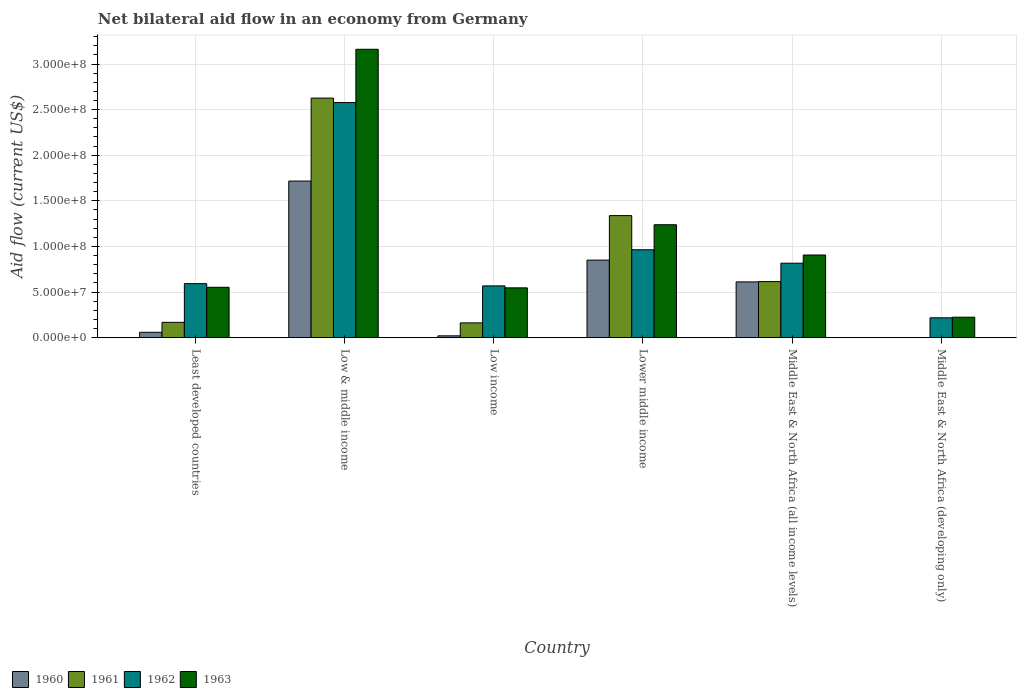How many groups of bars are there?
Offer a very short reply. 6. Are the number of bars on each tick of the X-axis equal?
Provide a succinct answer. No. What is the label of the 5th group of bars from the left?
Your answer should be very brief. Middle East & North Africa (all income levels). What is the net bilateral aid flow in 1960 in Low income?
Your response must be concise. 2.02e+06. Across all countries, what is the maximum net bilateral aid flow in 1962?
Ensure brevity in your answer.  2.58e+08. Across all countries, what is the minimum net bilateral aid flow in 1960?
Offer a terse response. 0. In which country was the net bilateral aid flow in 1961 maximum?
Provide a succinct answer. Low & middle income. What is the total net bilateral aid flow in 1963 in the graph?
Your answer should be very brief. 6.63e+08. What is the difference between the net bilateral aid flow in 1962 in Lower middle income and that in Middle East & North Africa (all income levels)?
Keep it short and to the point. 1.47e+07. What is the difference between the net bilateral aid flow in 1960 in Low income and the net bilateral aid flow in 1962 in Middle East & North Africa (all income levels)?
Your answer should be compact. -7.96e+07. What is the average net bilateral aid flow in 1962 per country?
Make the answer very short. 9.56e+07. What is the difference between the net bilateral aid flow of/in 1963 and net bilateral aid flow of/in 1962 in Low & middle income?
Offer a very short reply. 5.84e+07. What is the ratio of the net bilateral aid flow in 1960 in Lower middle income to that in Middle East & North Africa (all income levels)?
Offer a very short reply. 1.39. Is the net bilateral aid flow in 1961 in Least developed countries less than that in Middle East & North Africa (all income levels)?
Ensure brevity in your answer.  Yes. What is the difference between the highest and the second highest net bilateral aid flow in 1961?
Offer a very short reply. 2.01e+08. What is the difference between the highest and the lowest net bilateral aid flow in 1961?
Give a very brief answer. 2.63e+08. Are all the bars in the graph horizontal?
Provide a short and direct response. No. Are the values on the major ticks of Y-axis written in scientific E-notation?
Offer a very short reply. Yes. Does the graph contain grids?
Give a very brief answer. Yes. How are the legend labels stacked?
Your answer should be compact. Horizontal. What is the title of the graph?
Provide a succinct answer. Net bilateral aid flow in an economy from Germany. Does "2008" appear as one of the legend labels in the graph?
Keep it short and to the point. No. What is the Aid flow (current US$) of 1960 in Least developed countries?
Offer a terse response. 5.90e+06. What is the Aid flow (current US$) in 1961 in Least developed countries?
Make the answer very short. 1.68e+07. What is the Aid flow (current US$) of 1962 in Least developed countries?
Give a very brief answer. 5.92e+07. What is the Aid flow (current US$) of 1963 in Least developed countries?
Ensure brevity in your answer.  5.52e+07. What is the Aid flow (current US$) of 1960 in Low & middle income?
Offer a very short reply. 1.72e+08. What is the Aid flow (current US$) of 1961 in Low & middle income?
Keep it short and to the point. 2.63e+08. What is the Aid flow (current US$) of 1962 in Low & middle income?
Your answer should be very brief. 2.58e+08. What is the Aid flow (current US$) in 1963 in Low & middle income?
Ensure brevity in your answer.  3.16e+08. What is the Aid flow (current US$) in 1960 in Low income?
Offer a very short reply. 2.02e+06. What is the Aid flow (current US$) in 1961 in Low income?
Provide a succinct answer. 1.62e+07. What is the Aid flow (current US$) of 1962 in Low income?
Offer a very short reply. 5.68e+07. What is the Aid flow (current US$) in 1963 in Low income?
Your answer should be very brief. 5.46e+07. What is the Aid flow (current US$) of 1960 in Lower middle income?
Provide a succinct answer. 8.50e+07. What is the Aid flow (current US$) in 1961 in Lower middle income?
Your response must be concise. 1.34e+08. What is the Aid flow (current US$) of 1962 in Lower middle income?
Make the answer very short. 9.64e+07. What is the Aid flow (current US$) of 1963 in Lower middle income?
Your response must be concise. 1.24e+08. What is the Aid flow (current US$) in 1960 in Middle East & North Africa (all income levels)?
Give a very brief answer. 6.11e+07. What is the Aid flow (current US$) in 1961 in Middle East & North Africa (all income levels)?
Offer a terse response. 6.15e+07. What is the Aid flow (current US$) of 1962 in Middle East & North Africa (all income levels)?
Offer a terse response. 8.16e+07. What is the Aid flow (current US$) in 1963 in Middle East & North Africa (all income levels)?
Offer a very short reply. 9.06e+07. What is the Aid flow (current US$) in 1961 in Middle East & North Africa (developing only)?
Provide a succinct answer. 0. What is the Aid flow (current US$) in 1962 in Middle East & North Africa (developing only)?
Provide a short and direct response. 2.18e+07. What is the Aid flow (current US$) of 1963 in Middle East & North Africa (developing only)?
Offer a terse response. 2.24e+07. Across all countries, what is the maximum Aid flow (current US$) in 1960?
Your answer should be very brief. 1.72e+08. Across all countries, what is the maximum Aid flow (current US$) in 1961?
Offer a very short reply. 2.63e+08. Across all countries, what is the maximum Aid flow (current US$) of 1962?
Offer a very short reply. 2.58e+08. Across all countries, what is the maximum Aid flow (current US$) of 1963?
Provide a succinct answer. 3.16e+08. Across all countries, what is the minimum Aid flow (current US$) of 1960?
Provide a succinct answer. 0. Across all countries, what is the minimum Aid flow (current US$) of 1962?
Ensure brevity in your answer.  2.18e+07. Across all countries, what is the minimum Aid flow (current US$) in 1963?
Your answer should be compact. 2.24e+07. What is the total Aid flow (current US$) in 1960 in the graph?
Provide a succinct answer. 3.26e+08. What is the total Aid flow (current US$) of 1961 in the graph?
Provide a succinct answer. 4.91e+08. What is the total Aid flow (current US$) of 1962 in the graph?
Your answer should be very brief. 5.74e+08. What is the total Aid flow (current US$) of 1963 in the graph?
Keep it short and to the point. 6.63e+08. What is the difference between the Aid flow (current US$) of 1960 in Least developed countries and that in Low & middle income?
Your answer should be compact. -1.66e+08. What is the difference between the Aid flow (current US$) of 1961 in Least developed countries and that in Low & middle income?
Make the answer very short. -2.46e+08. What is the difference between the Aid flow (current US$) in 1962 in Least developed countries and that in Low & middle income?
Ensure brevity in your answer.  -1.99e+08. What is the difference between the Aid flow (current US$) in 1963 in Least developed countries and that in Low & middle income?
Offer a very short reply. -2.61e+08. What is the difference between the Aid flow (current US$) in 1960 in Least developed countries and that in Low income?
Offer a terse response. 3.88e+06. What is the difference between the Aid flow (current US$) of 1961 in Least developed countries and that in Low income?
Your answer should be compact. 6.10e+05. What is the difference between the Aid flow (current US$) in 1962 in Least developed countries and that in Low income?
Make the answer very short. 2.45e+06. What is the difference between the Aid flow (current US$) in 1963 in Least developed countries and that in Low income?
Your answer should be compact. 6.20e+05. What is the difference between the Aid flow (current US$) in 1960 in Least developed countries and that in Lower middle income?
Your answer should be very brief. -7.91e+07. What is the difference between the Aid flow (current US$) of 1961 in Least developed countries and that in Lower middle income?
Ensure brevity in your answer.  -1.17e+08. What is the difference between the Aid flow (current US$) of 1962 in Least developed countries and that in Lower middle income?
Your answer should be very brief. -3.71e+07. What is the difference between the Aid flow (current US$) in 1963 in Least developed countries and that in Lower middle income?
Ensure brevity in your answer.  -6.86e+07. What is the difference between the Aid flow (current US$) of 1960 in Least developed countries and that in Middle East & North Africa (all income levels)?
Provide a short and direct response. -5.52e+07. What is the difference between the Aid flow (current US$) in 1961 in Least developed countries and that in Middle East & North Africa (all income levels)?
Make the answer very short. -4.47e+07. What is the difference between the Aid flow (current US$) of 1962 in Least developed countries and that in Middle East & North Africa (all income levels)?
Offer a very short reply. -2.24e+07. What is the difference between the Aid flow (current US$) in 1963 in Least developed countries and that in Middle East & North Africa (all income levels)?
Keep it short and to the point. -3.54e+07. What is the difference between the Aid flow (current US$) in 1962 in Least developed countries and that in Middle East & North Africa (developing only)?
Keep it short and to the point. 3.74e+07. What is the difference between the Aid flow (current US$) in 1963 in Least developed countries and that in Middle East & North Africa (developing only)?
Keep it short and to the point. 3.28e+07. What is the difference between the Aid flow (current US$) in 1960 in Low & middle income and that in Low income?
Give a very brief answer. 1.70e+08. What is the difference between the Aid flow (current US$) in 1961 in Low & middle income and that in Low income?
Your answer should be very brief. 2.46e+08. What is the difference between the Aid flow (current US$) in 1962 in Low & middle income and that in Low income?
Keep it short and to the point. 2.01e+08. What is the difference between the Aid flow (current US$) of 1963 in Low & middle income and that in Low income?
Your answer should be compact. 2.62e+08. What is the difference between the Aid flow (current US$) in 1960 in Low & middle income and that in Lower middle income?
Your response must be concise. 8.67e+07. What is the difference between the Aid flow (current US$) in 1961 in Low & middle income and that in Lower middle income?
Offer a terse response. 1.29e+08. What is the difference between the Aid flow (current US$) in 1962 in Low & middle income and that in Lower middle income?
Your response must be concise. 1.61e+08. What is the difference between the Aid flow (current US$) in 1963 in Low & middle income and that in Lower middle income?
Offer a terse response. 1.92e+08. What is the difference between the Aid flow (current US$) of 1960 in Low & middle income and that in Middle East & North Africa (all income levels)?
Offer a very short reply. 1.11e+08. What is the difference between the Aid flow (current US$) in 1961 in Low & middle income and that in Middle East & North Africa (all income levels)?
Your answer should be very brief. 2.01e+08. What is the difference between the Aid flow (current US$) of 1962 in Low & middle income and that in Middle East & North Africa (all income levels)?
Offer a terse response. 1.76e+08. What is the difference between the Aid flow (current US$) in 1963 in Low & middle income and that in Middle East & North Africa (all income levels)?
Provide a succinct answer. 2.26e+08. What is the difference between the Aid flow (current US$) of 1962 in Low & middle income and that in Middle East & North Africa (developing only)?
Offer a very short reply. 2.36e+08. What is the difference between the Aid flow (current US$) of 1963 in Low & middle income and that in Middle East & North Africa (developing only)?
Provide a succinct answer. 2.94e+08. What is the difference between the Aid flow (current US$) of 1960 in Low income and that in Lower middle income?
Your response must be concise. -8.30e+07. What is the difference between the Aid flow (current US$) of 1961 in Low income and that in Lower middle income?
Offer a terse response. -1.18e+08. What is the difference between the Aid flow (current US$) in 1962 in Low income and that in Lower middle income?
Provide a short and direct response. -3.96e+07. What is the difference between the Aid flow (current US$) in 1963 in Low income and that in Lower middle income?
Ensure brevity in your answer.  -6.92e+07. What is the difference between the Aid flow (current US$) of 1960 in Low income and that in Middle East & North Africa (all income levels)?
Provide a succinct answer. -5.91e+07. What is the difference between the Aid flow (current US$) of 1961 in Low income and that in Middle East & North Africa (all income levels)?
Give a very brief answer. -4.53e+07. What is the difference between the Aid flow (current US$) in 1962 in Low income and that in Middle East & North Africa (all income levels)?
Make the answer very short. -2.49e+07. What is the difference between the Aid flow (current US$) of 1963 in Low income and that in Middle East & North Africa (all income levels)?
Give a very brief answer. -3.60e+07. What is the difference between the Aid flow (current US$) in 1962 in Low income and that in Middle East & North Africa (developing only)?
Provide a succinct answer. 3.50e+07. What is the difference between the Aid flow (current US$) of 1963 in Low income and that in Middle East & North Africa (developing only)?
Provide a short and direct response. 3.22e+07. What is the difference between the Aid flow (current US$) of 1960 in Lower middle income and that in Middle East & North Africa (all income levels)?
Offer a very short reply. 2.39e+07. What is the difference between the Aid flow (current US$) in 1961 in Lower middle income and that in Middle East & North Africa (all income levels)?
Ensure brevity in your answer.  7.24e+07. What is the difference between the Aid flow (current US$) in 1962 in Lower middle income and that in Middle East & North Africa (all income levels)?
Offer a very short reply. 1.47e+07. What is the difference between the Aid flow (current US$) of 1963 in Lower middle income and that in Middle East & North Africa (all income levels)?
Ensure brevity in your answer.  3.32e+07. What is the difference between the Aid flow (current US$) of 1962 in Lower middle income and that in Middle East & North Africa (developing only)?
Provide a short and direct response. 7.46e+07. What is the difference between the Aid flow (current US$) in 1963 in Lower middle income and that in Middle East & North Africa (developing only)?
Your answer should be compact. 1.01e+08. What is the difference between the Aid flow (current US$) in 1962 in Middle East & North Africa (all income levels) and that in Middle East & North Africa (developing only)?
Ensure brevity in your answer.  5.99e+07. What is the difference between the Aid flow (current US$) of 1963 in Middle East & North Africa (all income levels) and that in Middle East & North Africa (developing only)?
Keep it short and to the point. 6.82e+07. What is the difference between the Aid flow (current US$) in 1960 in Least developed countries and the Aid flow (current US$) in 1961 in Low & middle income?
Your answer should be compact. -2.57e+08. What is the difference between the Aid flow (current US$) in 1960 in Least developed countries and the Aid flow (current US$) in 1962 in Low & middle income?
Keep it short and to the point. -2.52e+08. What is the difference between the Aid flow (current US$) in 1960 in Least developed countries and the Aid flow (current US$) in 1963 in Low & middle income?
Your response must be concise. -3.10e+08. What is the difference between the Aid flow (current US$) in 1961 in Least developed countries and the Aid flow (current US$) in 1962 in Low & middle income?
Offer a terse response. -2.41e+08. What is the difference between the Aid flow (current US$) in 1961 in Least developed countries and the Aid flow (current US$) in 1963 in Low & middle income?
Keep it short and to the point. -2.99e+08. What is the difference between the Aid flow (current US$) of 1962 in Least developed countries and the Aid flow (current US$) of 1963 in Low & middle income?
Your answer should be very brief. -2.57e+08. What is the difference between the Aid flow (current US$) of 1960 in Least developed countries and the Aid flow (current US$) of 1961 in Low income?
Make the answer very short. -1.03e+07. What is the difference between the Aid flow (current US$) in 1960 in Least developed countries and the Aid flow (current US$) in 1962 in Low income?
Provide a succinct answer. -5.09e+07. What is the difference between the Aid flow (current US$) in 1960 in Least developed countries and the Aid flow (current US$) in 1963 in Low income?
Provide a succinct answer. -4.87e+07. What is the difference between the Aid flow (current US$) in 1961 in Least developed countries and the Aid flow (current US$) in 1962 in Low income?
Your answer should be compact. -4.00e+07. What is the difference between the Aid flow (current US$) of 1961 in Least developed countries and the Aid flow (current US$) of 1963 in Low income?
Provide a short and direct response. -3.78e+07. What is the difference between the Aid flow (current US$) of 1962 in Least developed countries and the Aid flow (current US$) of 1963 in Low income?
Keep it short and to the point. 4.61e+06. What is the difference between the Aid flow (current US$) in 1960 in Least developed countries and the Aid flow (current US$) in 1961 in Lower middle income?
Your answer should be very brief. -1.28e+08. What is the difference between the Aid flow (current US$) in 1960 in Least developed countries and the Aid flow (current US$) in 1962 in Lower middle income?
Your response must be concise. -9.05e+07. What is the difference between the Aid flow (current US$) of 1960 in Least developed countries and the Aid flow (current US$) of 1963 in Lower middle income?
Offer a very short reply. -1.18e+08. What is the difference between the Aid flow (current US$) in 1961 in Least developed countries and the Aid flow (current US$) in 1962 in Lower middle income?
Ensure brevity in your answer.  -7.96e+07. What is the difference between the Aid flow (current US$) of 1961 in Least developed countries and the Aid flow (current US$) of 1963 in Lower middle income?
Offer a very short reply. -1.07e+08. What is the difference between the Aid flow (current US$) in 1962 in Least developed countries and the Aid flow (current US$) in 1963 in Lower middle income?
Your response must be concise. -6.46e+07. What is the difference between the Aid flow (current US$) in 1960 in Least developed countries and the Aid flow (current US$) in 1961 in Middle East & North Africa (all income levels)?
Keep it short and to the point. -5.56e+07. What is the difference between the Aid flow (current US$) in 1960 in Least developed countries and the Aid flow (current US$) in 1962 in Middle East & North Africa (all income levels)?
Provide a short and direct response. -7.57e+07. What is the difference between the Aid flow (current US$) of 1960 in Least developed countries and the Aid flow (current US$) of 1963 in Middle East & North Africa (all income levels)?
Provide a succinct answer. -8.47e+07. What is the difference between the Aid flow (current US$) in 1961 in Least developed countries and the Aid flow (current US$) in 1962 in Middle East & North Africa (all income levels)?
Your answer should be compact. -6.48e+07. What is the difference between the Aid flow (current US$) of 1961 in Least developed countries and the Aid flow (current US$) of 1963 in Middle East & North Africa (all income levels)?
Offer a terse response. -7.38e+07. What is the difference between the Aid flow (current US$) in 1962 in Least developed countries and the Aid flow (current US$) in 1963 in Middle East & North Africa (all income levels)?
Your answer should be compact. -3.14e+07. What is the difference between the Aid flow (current US$) of 1960 in Least developed countries and the Aid flow (current US$) of 1962 in Middle East & North Africa (developing only)?
Make the answer very short. -1.59e+07. What is the difference between the Aid flow (current US$) of 1960 in Least developed countries and the Aid flow (current US$) of 1963 in Middle East & North Africa (developing only)?
Keep it short and to the point. -1.65e+07. What is the difference between the Aid flow (current US$) of 1961 in Least developed countries and the Aid flow (current US$) of 1962 in Middle East & North Africa (developing only)?
Provide a short and direct response. -4.96e+06. What is the difference between the Aid flow (current US$) of 1961 in Least developed countries and the Aid flow (current US$) of 1963 in Middle East & North Africa (developing only)?
Provide a short and direct response. -5.63e+06. What is the difference between the Aid flow (current US$) of 1962 in Least developed countries and the Aid flow (current US$) of 1963 in Middle East & North Africa (developing only)?
Your answer should be very brief. 3.68e+07. What is the difference between the Aid flow (current US$) of 1960 in Low & middle income and the Aid flow (current US$) of 1961 in Low income?
Your answer should be compact. 1.55e+08. What is the difference between the Aid flow (current US$) of 1960 in Low & middle income and the Aid flow (current US$) of 1962 in Low income?
Provide a succinct answer. 1.15e+08. What is the difference between the Aid flow (current US$) of 1960 in Low & middle income and the Aid flow (current US$) of 1963 in Low income?
Offer a very short reply. 1.17e+08. What is the difference between the Aid flow (current US$) in 1961 in Low & middle income and the Aid flow (current US$) in 1962 in Low income?
Make the answer very short. 2.06e+08. What is the difference between the Aid flow (current US$) in 1961 in Low & middle income and the Aid flow (current US$) in 1963 in Low income?
Make the answer very short. 2.08e+08. What is the difference between the Aid flow (current US$) of 1962 in Low & middle income and the Aid flow (current US$) of 1963 in Low income?
Ensure brevity in your answer.  2.03e+08. What is the difference between the Aid flow (current US$) in 1960 in Low & middle income and the Aid flow (current US$) in 1961 in Lower middle income?
Offer a terse response. 3.79e+07. What is the difference between the Aid flow (current US$) in 1960 in Low & middle income and the Aid flow (current US$) in 1962 in Lower middle income?
Your response must be concise. 7.53e+07. What is the difference between the Aid flow (current US$) in 1960 in Low & middle income and the Aid flow (current US$) in 1963 in Lower middle income?
Your answer should be compact. 4.79e+07. What is the difference between the Aid flow (current US$) of 1961 in Low & middle income and the Aid flow (current US$) of 1962 in Lower middle income?
Offer a terse response. 1.66e+08. What is the difference between the Aid flow (current US$) in 1961 in Low & middle income and the Aid flow (current US$) in 1963 in Lower middle income?
Your response must be concise. 1.39e+08. What is the difference between the Aid flow (current US$) of 1962 in Low & middle income and the Aid flow (current US$) of 1963 in Lower middle income?
Provide a short and direct response. 1.34e+08. What is the difference between the Aid flow (current US$) in 1960 in Low & middle income and the Aid flow (current US$) in 1961 in Middle East & North Africa (all income levels)?
Offer a very short reply. 1.10e+08. What is the difference between the Aid flow (current US$) of 1960 in Low & middle income and the Aid flow (current US$) of 1962 in Middle East & North Africa (all income levels)?
Keep it short and to the point. 9.00e+07. What is the difference between the Aid flow (current US$) in 1960 in Low & middle income and the Aid flow (current US$) in 1963 in Middle East & North Africa (all income levels)?
Give a very brief answer. 8.11e+07. What is the difference between the Aid flow (current US$) in 1961 in Low & middle income and the Aid flow (current US$) in 1962 in Middle East & North Africa (all income levels)?
Ensure brevity in your answer.  1.81e+08. What is the difference between the Aid flow (current US$) of 1961 in Low & middle income and the Aid flow (current US$) of 1963 in Middle East & North Africa (all income levels)?
Your response must be concise. 1.72e+08. What is the difference between the Aid flow (current US$) of 1962 in Low & middle income and the Aid flow (current US$) of 1963 in Middle East & North Africa (all income levels)?
Your answer should be compact. 1.67e+08. What is the difference between the Aid flow (current US$) in 1960 in Low & middle income and the Aid flow (current US$) in 1962 in Middle East & North Africa (developing only)?
Make the answer very short. 1.50e+08. What is the difference between the Aid flow (current US$) of 1960 in Low & middle income and the Aid flow (current US$) of 1963 in Middle East & North Africa (developing only)?
Ensure brevity in your answer.  1.49e+08. What is the difference between the Aid flow (current US$) in 1961 in Low & middle income and the Aid flow (current US$) in 1962 in Middle East & North Africa (developing only)?
Keep it short and to the point. 2.41e+08. What is the difference between the Aid flow (current US$) of 1961 in Low & middle income and the Aid flow (current US$) of 1963 in Middle East & North Africa (developing only)?
Your answer should be very brief. 2.40e+08. What is the difference between the Aid flow (current US$) of 1962 in Low & middle income and the Aid flow (current US$) of 1963 in Middle East & North Africa (developing only)?
Ensure brevity in your answer.  2.35e+08. What is the difference between the Aid flow (current US$) of 1960 in Low income and the Aid flow (current US$) of 1961 in Lower middle income?
Offer a very short reply. -1.32e+08. What is the difference between the Aid flow (current US$) in 1960 in Low income and the Aid flow (current US$) in 1962 in Lower middle income?
Ensure brevity in your answer.  -9.43e+07. What is the difference between the Aid flow (current US$) in 1960 in Low income and the Aid flow (current US$) in 1963 in Lower middle income?
Provide a short and direct response. -1.22e+08. What is the difference between the Aid flow (current US$) of 1961 in Low income and the Aid flow (current US$) of 1962 in Lower middle income?
Provide a succinct answer. -8.02e+07. What is the difference between the Aid flow (current US$) in 1961 in Low income and the Aid flow (current US$) in 1963 in Lower middle income?
Ensure brevity in your answer.  -1.08e+08. What is the difference between the Aid flow (current US$) in 1962 in Low income and the Aid flow (current US$) in 1963 in Lower middle income?
Offer a terse response. -6.70e+07. What is the difference between the Aid flow (current US$) in 1960 in Low income and the Aid flow (current US$) in 1961 in Middle East & North Africa (all income levels)?
Make the answer very short. -5.94e+07. What is the difference between the Aid flow (current US$) in 1960 in Low income and the Aid flow (current US$) in 1962 in Middle East & North Africa (all income levels)?
Your response must be concise. -7.96e+07. What is the difference between the Aid flow (current US$) in 1960 in Low income and the Aid flow (current US$) in 1963 in Middle East & North Africa (all income levels)?
Give a very brief answer. -8.86e+07. What is the difference between the Aid flow (current US$) in 1961 in Low income and the Aid flow (current US$) in 1962 in Middle East & North Africa (all income levels)?
Offer a very short reply. -6.54e+07. What is the difference between the Aid flow (current US$) of 1961 in Low income and the Aid flow (current US$) of 1963 in Middle East & North Africa (all income levels)?
Make the answer very short. -7.44e+07. What is the difference between the Aid flow (current US$) of 1962 in Low income and the Aid flow (current US$) of 1963 in Middle East & North Africa (all income levels)?
Keep it short and to the point. -3.38e+07. What is the difference between the Aid flow (current US$) in 1960 in Low income and the Aid flow (current US$) in 1962 in Middle East & North Africa (developing only)?
Offer a terse response. -1.98e+07. What is the difference between the Aid flow (current US$) of 1960 in Low income and the Aid flow (current US$) of 1963 in Middle East & North Africa (developing only)?
Provide a short and direct response. -2.04e+07. What is the difference between the Aid flow (current US$) in 1961 in Low income and the Aid flow (current US$) in 1962 in Middle East & North Africa (developing only)?
Keep it short and to the point. -5.57e+06. What is the difference between the Aid flow (current US$) of 1961 in Low income and the Aid flow (current US$) of 1963 in Middle East & North Africa (developing only)?
Your answer should be compact. -6.24e+06. What is the difference between the Aid flow (current US$) of 1962 in Low income and the Aid flow (current US$) of 1963 in Middle East & North Africa (developing only)?
Your answer should be very brief. 3.43e+07. What is the difference between the Aid flow (current US$) in 1960 in Lower middle income and the Aid flow (current US$) in 1961 in Middle East & North Africa (all income levels)?
Offer a very short reply. 2.36e+07. What is the difference between the Aid flow (current US$) of 1960 in Lower middle income and the Aid flow (current US$) of 1962 in Middle East & North Africa (all income levels)?
Give a very brief answer. 3.38e+06. What is the difference between the Aid flow (current US$) in 1960 in Lower middle income and the Aid flow (current US$) in 1963 in Middle East & North Africa (all income levels)?
Provide a succinct answer. -5.59e+06. What is the difference between the Aid flow (current US$) in 1961 in Lower middle income and the Aid flow (current US$) in 1962 in Middle East & North Africa (all income levels)?
Offer a terse response. 5.22e+07. What is the difference between the Aid flow (current US$) of 1961 in Lower middle income and the Aid flow (current US$) of 1963 in Middle East & North Africa (all income levels)?
Your answer should be compact. 4.32e+07. What is the difference between the Aid flow (current US$) in 1962 in Lower middle income and the Aid flow (current US$) in 1963 in Middle East & North Africa (all income levels)?
Your answer should be very brief. 5.75e+06. What is the difference between the Aid flow (current US$) of 1960 in Lower middle income and the Aid flow (current US$) of 1962 in Middle East & North Africa (developing only)?
Provide a succinct answer. 6.32e+07. What is the difference between the Aid flow (current US$) of 1960 in Lower middle income and the Aid flow (current US$) of 1963 in Middle East & North Africa (developing only)?
Keep it short and to the point. 6.26e+07. What is the difference between the Aid flow (current US$) in 1961 in Lower middle income and the Aid flow (current US$) in 1962 in Middle East & North Africa (developing only)?
Keep it short and to the point. 1.12e+08. What is the difference between the Aid flow (current US$) in 1961 in Lower middle income and the Aid flow (current US$) in 1963 in Middle East & North Africa (developing only)?
Your response must be concise. 1.11e+08. What is the difference between the Aid flow (current US$) in 1962 in Lower middle income and the Aid flow (current US$) in 1963 in Middle East & North Africa (developing only)?
Make the answer very short. 7.39e+07. What is the difference between the Aid flow (current US$) of 1960 in Middle East & North Africa (all income levels) and the Aid flow (current US$) of 1962 in Middle East & North Africa (developing only)?
Your answer should be very brief. 3.94e+07. What is the difference between the Aid flow (current US$) in 1960 in Middle East & North Africa (all income levels) and the Aid flow (current US$) in 1963 in Middle East & North Africa (developing only)?
Give a very brief answer. 3.87e+07. What is the difference between the Aid flow (current US$) in 1961 in Middle East & North Africa (all income levels) and the Aid flow (current US$) in 1962 in Middle East & North Africa (developing only)?
Offer a terse response. 3.97e+07. What is the difference between the Aid flow (current US$) in 1961 in Middle East & North Africa (all income levels) and the Aid flow (current US$) in 1963 in Middle East & North Africa (developing only)?
Make the answer very short. 3.90e+07. What is the difference between the Aid flow (current US$) of 1962 in Middle East & North Africa (all income levels) and the Aid flow (current US$) of 1963 in Middle East & North Africa (developing only)?
Provide a succinct answer. 5.92e+07. What is the average Aid flow (current US$) of 1960 per country?
Give a very brief answer. 5.43e+07. What is the average Aid flow (current US$) of 1961 per country?
Your answer should be compact. 8.18e+07. What is the average Aid flow (current US$) in 1962 per country?
Offer a terse response. 9.56e+07. What is the average Aid flow (current US$) in 1963 per country?
Your answer should be very brief. 1.10e+08. What is the difference between the Aid flow (current US$) in 1960 and Aid flow (current US$) in 1961 in Least developed countries?
Provide a short and direct response. -1.09e+07. What is the difference between the Aid flow (current US$) in 1960 and Aid flow (current US$) in 1962 in Least developed countries?
Keep it short and to the point. -5.33e+07. What is the difference between the Aid flow (current US$) in 1960 and Aid flow (current US$) in 1963 in Least developed countries?
Provide a succinct answer. -4.93e+07. What is the difference between the Aid flow (current US$) in 1961 and Aid flow (current US$) in 1962 in Least developed countries?
Your answer should be compact. -4.24e+07. What is the difference between the Aid flow (current US$) of 1961 and Aid flow (current US$) of 1963 in Least developed countries?
Your response must be concise. -3.84e+07. What is the difference between the Aid flow (current US$) in 1962 and Aid flow (current US$) in 1963 in Least developed countries?
Keep it short and to the point. 3.99e+06. What is the difference between the Aid flow (current US$) in 1960 and Aid flow (current US$) in 1961 in Low & middle income?
Provide a short and direct response. -9.09e+07. What is the difference between the Aid flow (current US$) of 1960 and Aid flow (current US$) of 1962 in Low & middle income?
Your answer should be compact. -8.61e+07. What is the difference between the Aid flow (current US$) in 1960 and Aid flow (current US$) in 1963 in Low & middle income?
Provide a short and direct response. -1.44e+08. What is the difference between the Aid flow (current US$) in 1961 and Aid flow (current US$) in 1962 in Low & middle income?
Provide a succinct answer. 4.87e+06. What is the difference between the Aid flow (current US$) in 1961 and Aid flow (current US$) in 1963 in Low & middle income?
Provide a short and direct response. -5.35e+07. What is the difference between the Aid flow (current US$) of 1962 and Aid flow (current US$) of 1963 in Low & middle income?
Your answer should be compact. -5.84e+07. What is the difference between the Aid flow (current US$) in 1960 and Aid flow (current US$) in 1961 in Low income?
Your answer should be very brief. -1.42e+07. What is the difference between the Aid flow (current US$) in 1960 and Aid flow (current US$) in 1962 in Low income?
Make the answer very short. -5.48e+07. What is the difference between the Aid flow (current US$) of 1960 and Aid flow (current US$) of 1963 in Low income?
Your answer should be very brief. -5.26e+07. What is the difference between the Aid flow (current US$) of 1961 and Aid flow (current US$) of 1962 in Low income?
Provide a short and direct response. -4.06e+07. What is the difference between the Aid flow (current US$) of 1961 and Aid flow (current US$) of 1963 in Low income?
Your answer should be compact. -3.84e+07. What is the difference between the Aid flow (current US$) in 1962 and Aid flow (current US$) in 1963 in Low income?
Provide a short and direct response. 2.16e+06. What is the difference between the Aid flow (current US$) in 1960 and Aid flow (current US$) in 1961 in Lower middle income?
Offer a terse response. -4.88e+07. What is the difference between the Aid flow (current US$) in 1960 and Aid flow (current US$) in 1962 in Lower middle income?
Make the answer very short. -1.13e+07. What is the difference between the Aid flow (current US$) in 1960 and Aid flow (current US$) in 1963 in Lower middle income?
Provide a short and direct response. -3.88e+07. What is the difference between the Aid flow (current US$) in 1961 and Aid flow (current US$) in 1962 in Lower middle income?
Provide a short and direct response. 3.75e+07. What is the difference between the Aid flow (current US$) in 1961 and Aid flow (current US$) in 1963 in Lower middle income?
Provide a succinct answer. 1.00e+07. What is the difference between the Aid flow (current US$) in 1962 and Aid flow (current US$) in 1963 in Lower middle income?
Make the answer very short. -2.74e+07. What is the difference between the Aid flow (current US$) in 1960 and Aid flow (current US$) in 1961 in Middle East & North Africa (all income levels)?
Ensure brevity in your answer.  -3.30e+05. What is the difference between the Aid flow (current US$) in 1960 and Aid flow (current US$) in 1962 in Middle East & North Africa (all income levels)?
Provide a short and direct response. -2.05e+07. What is the difference between the Aid flow (current US$) of 1960 and Aid flow (current US$) of 1963 in Middle East & North Africa (all income levels)?
Your answer should be very brief. -2.95e+07. What is the difference between the Aid flow (current US$) of 1961 and Aid flow (current US$) of 1962 in Middle East & North Africa (all income levels)?
Offer a terse response. -2.02e+07. What is the difference between the Aid flow (current US$) in 1961 and Aid flow (current US$) in 1963 in Middle East & North Africa (all income levels)?
Ensure brevity in your answer.  -2.91e+07. What is the difference between the Aid flow (current US$) of 1962 and Aid flow (current US$) of 1963 in Middle East & North Africa (all income levels)?
Provide a succinct answer. -8.97e+06. What is the difference between the Aid flow (current US$) in 1962 and Aid flow (current US$) in 1963 in Middle East & North Africa (developing only)?
Provide a succinct answer. -6.70e+05. What is the ratio of the Aid flow (current US$) of 1960 in Least developed countries to that in Low & middle income?
Provide a short and direct response. 0.03. What is the ratio of the Aid flow (current US$) in 1961 in Least developed countries to that in Low & middle income?
Keep it short and to the point. 0.06. What is the ratio of the Aid flow (current US$) in 1962 in Least developed countries to that in Low & middle income?
Your answer should be very brief. 0.23. What is the ratio of the Aid flow (current US$) in 1963 in Least developed countries to that in Low & middle income?
Provide a short and direct response. 0.17. What is the ratio of the Aid flow (current US$) of 1960 in Least developed countries to that in Low income?
Provide a short and direct response. 2.92. What is the ratio of the Aid flow (current US$) in 1961 in Least developed countries to that in Low income?
Your answer should be very brief. 1.04. What is the ratio of the Aid flow (current US$) of 1962 in Least developed countries to that in Low income?
Provide a succinct answer. 1.04. What is the ratio of the Aid flow (current US$) of 1963 in Least developed countries to that in Low income?
Your answer should be very brief. 1.01. What is the ratio of the Aid flow (current US$) in 1960 in Least developed countries to that in Lower middle income?
Make the answer very short. 0.07. What is the ratio of the Aid flow (current US$) of 1961 in Least developed countries to that in Lower middle income?
Your response must be concise. 0.13. What is the ratio of the Aid flow (current US$) in 1962 in Least developed countries to that in Lower middle income?
Your answer should be very brief. 0.61. What is the ratio of the Aid flow (current US$) in 1963 in Least developed countries to that in Lower middle income?
Make the answer very short. 0.45. What is the ratio of the Aid flow (current US$) of 1960 in Least developed countries to that in Middle East & North Africa (all income levels)?
Ensure brevity in your answer.  0.1. What is the ratio of the Aid flow (current US$) in 1961 in Least developed countries to that in Middle East & North Africa (all income levels)?
Provide a succinct answer. 0.27. What is the ratio of the Aid flow (current US$) of 1962 in Least developed countries to that in Middle East & North Africa (all income levels)?
Offer a terse response. 0.73. What is the ratio of the Aid flow (current US$) in 1963 in Least developed countries to that in Middle East & North Africa (all income levels)?
Your response must be concise. 0.61. What is the ratio of the Aid flow (current US$) in 1962 in Least developed countries to that in Middle East & North Africa (developing only)?
Your answer should be compact. 2.72. What is the ratio of the Aid flow (current US$) in 1963 in Least developed countries to that in Middle East & North Africa (developing only)?
Offer a very short reply. 2.46. What is the ratio of the Aid flow (current US$) of 1960 in Low & middle income to that in Low income?
Your answer should be very brief. 85. What is the ratio of the Aid flow (current US$) of 1961 in Low & middle income to that in Low income?
Your answer should be very brief. 16.21. What is the ratio of the Aid flow (current US$) in 1962 in Low & middle income to that in Low income?
Your answer should be compact. 4.54. What is the ratio of the Aid flow (current US$) of 1963 in Low & middle income to that in Low income?
Keep it short and to the point. 5.79. What is the ratio of the Aid flow (current US$) in 1960 in Low & middle income to that in Lower middle income?
Your answer should be compact. 2.02. What is the ratio of the Aid flow (current US$) in 1961 in Low & middle income to that in Lower middle income?
Your response must be concise. 1.96. What is the ratio of the Aid flow (current US$) of 1962 in Low & middle income to that in Lower middle income?
Give a very brief answer. 2.67. What is the ratio of the Aid flow (current US$) of 1963 in Low & middle income to that in Lower middle income?
Your answer should be very brief. 2.55. What is the ratio of the Aid flow (current US$) in 1960 in Low & middle income to that in Middle East & North Africa (all income levels)?
Offer a very short reply. 2.81. What is the ratio of the Aid flow (current US$) of 1961 in Low & middle income to that in Middle East & North Africa (all income levels)?
Provide a succinct answer. 4.27. What is the ratio of the Aid flow (current US$) in 1962 in Low & middle income to that in Middle East & North Africa (all income levels)?
Offer a very short reply. 3.16. What is the ratio of the Aid flow (current US$) in 1963 in Low & middle income to that in Middle East & North Africa (all income levels)?
Your answer should be very brief. 3.49. What is the ratio of the Aid flow (current US$) in 1962 in Low & middle income to that in Middle East & North Africa (developing only)?
Give a very brief answer. 11.84. What is the ratio of the Aid flow (current US$) of 1963 in Low & middle income to that in Middle East & North Africa (developing only)?
Offer a terse response. 14.09. What is the ratio of the Aid flow (current US$) in 1960 in Low income to that in Lower middle income?
Give a very brief answer. 0.02. What is the ratio of the Aid flow (current US$) of 1961 in Low income to that in Lower middle income?
Make the answer very short. 0.12. What is the ratio of the Aid flow (current US$) of 1962 in Low income to that in Lower middle income?
Your answer should be very brief. 0.59. What is the ratio of the Aid flow (current US$) of 1963 in Low income to that in Lower middle income?
Your answer should be very brief. 0.44. What is the ratio of the Aid flow (current US$) in 1960 in Low income to that in Middle East & North Africa (all income levels)?
Your response must be concise. 0.03. What is the ratio of the Aid flow (current US$) of 1961 in Low income to that in Middle East & North Africa (all income levels)?
Your answer should be very brief. 0.26. What is the ratio of the Aid flow (current US$) of 1962 in Low income to that in Middle East & North Africa (all income levels)?
Keep it short and to the point. 0.7. What is the ratio of the Aid flow (current US$) of 1963 in Low income to that in Middle East & North Africa (all income levels)?
Provide a short and direct response. 0.6. What is the ratio of the Aid flow (current US$) in 1962 in Low income to that in Middle East & North Africa (developing only)?
Offer a terse response. 2.61. What is the ratio of the Aid flow (current US$) of 1963 in Low income to that in Middle East & North Africa (developing only)?
Provide a short and direct response. 2.43. What is the ratio of the Aid flow (current US$) in 1960 in Lower middle income to that in Middle East & North Africa (all income levels)?
Give a very brief answer. 1.39. What is the ratio of the Aid flow (current US$) in 1961 in Lower middle income to that in Middle East & North Africa (all income levels)?
Offer a terse response. 2.18. What is the ratio of the Aid flow (current US$) in 1962 in Lower middle income to that in Middle East & North Africa (all income levels)?
Provide a succinct answer. 1.18. What is the ratio of the Aid flow (current US$) in 1963 in Lower middle income to that in Middle East & North Africa (all income levels)?
Provide a short and direct response. 1.37. What is the ratio of the Aid flow (current US$) in 1962 in Lower middle income to that in Middle East & North Africa (developing only)?
Your answer should be very brief. 4.43. What is the ratio of the Aid flow (current US$) in 1963 in Lower middle income to that in Middle East & North Africa (developing only)?
Offer a very short reply. 5.52. What is the ratio of the Aid flow (current US$) of 1962 in Middle East & North Africa (all income levels) to that in Middle East & North Africa (developing only)?
Keep it short and to the point. 3.75. What is the ratio of the Aid flow (current US$) in 1963 in Middle East & North Africa (all income levels) to that in Middle East & North Africa (developing only)?
Make the answer very short. 4.04. What is the difference between the highest and the second highest Aid flow (current US$) in 1960?
Your answer should be compact. 8.67e+07. What is the difference between the highest and the second highest Aid flow (current US$) in 1961?
Your response must be concise. 1.29e+08. What is the difference between the highest and the second highest Aid flow (current US$) of 1962?
Provide a short and direct response. 1.61e+08. What is the difference between the highest and the second highest Aid flow (current US$) of 1963?
Your response must be concise. 1.92e+08. What is the difference between the highest and the lowest Aid flow (current US$) of 1960?
Your response must be concise. 1.72e+08. What is the difference between the highest and the lowest Aid flow (current US$) in 1961?
Keep it short and to the point. 2.63e+08. What is the difference between the highest and the lowest Aid flow (current US$) of 1962?
Offer a very short reply. 2.36e+08. What is the difference between the highest and the lowest Aid flow (current US$) of 1963?
Provide a short and direct response. 2.94e+08. 